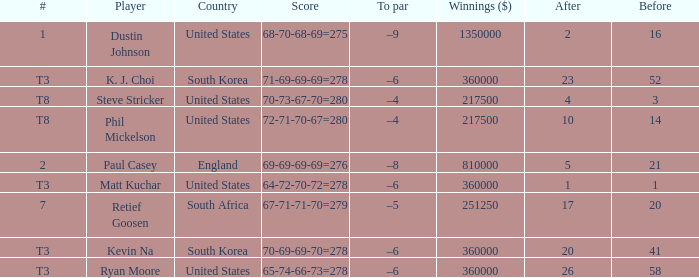How many times is  a to par listed when the player is phil mickelson? 1.0. 